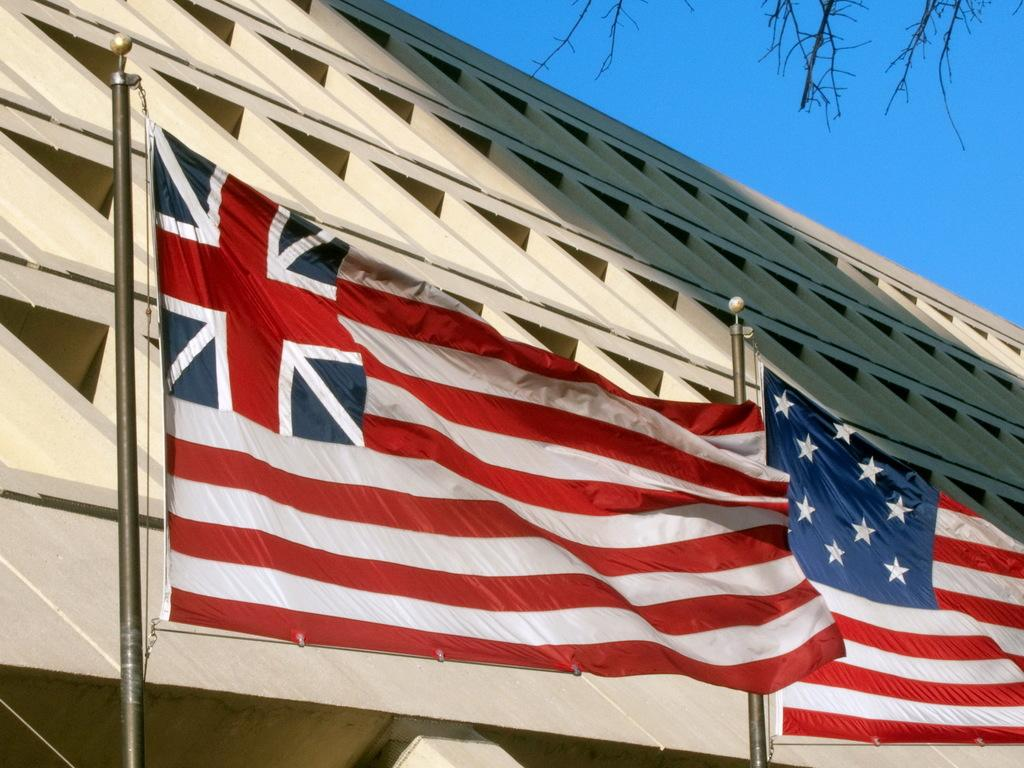What can be seen at the bottom of the poles in the image? There are flags at the bottom of the poles in the image. What is the position of the flags in relation to the poles? The flags are at the bottom of the poles. What is visible in the background of the image? There is a building in the background of the image. What can be seen in the top right corner of the image? The sky and a tree are visible in the top right corner of the image. How many friends does the tree in the image have? There is no indication of friends in the image, as it only features poles with flags, a building, and a tree. 